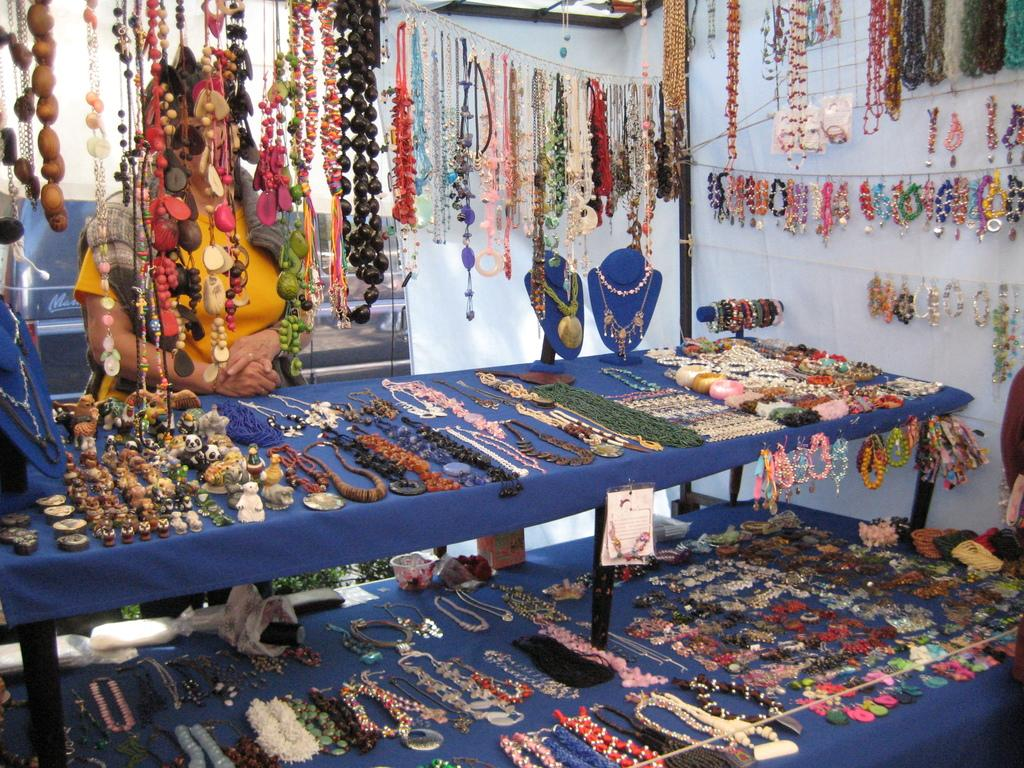What type of items can be seen in the image? There are many jewelry items in the image. How are the jewelry items arranged in the image? The jewelry is placed on the floor, and some are hanged on strings. Is there anyone present in the image? Yes, there is a woman standing behind the jewelry in the image. What can be seen in the background of the image? Creepers are visible in the background of the image. What type of ice can be seen melting on the jewelry in the image? There is no ice present in the image; it features jewelry placed on the floor and hanged on strings. 